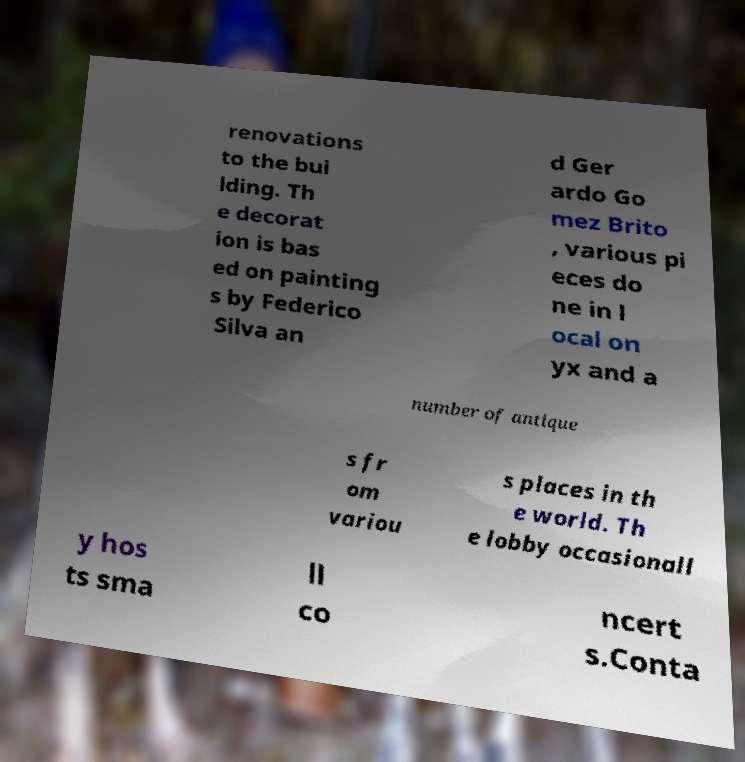There's text embedded in this image that I need extracted. Can you transcribe it verbatim? renovations to the bui lding. Th e decorat ion is bas ed on painting s by Federico Silva an d Ger ardo Go mez Brito , various pi eces do ne in l ocal on yx and a number of antique s fr om variou s places in th e world. Th e lobby occasionall y hos ts sma ll co ncert s.Conta 